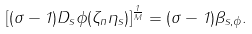<formula> <loc_0><loc_0><loc_500><loc_500>[ ( \sigma - 1 ) D _ { s } \phi ( \zeta _ { n } \eta _ { s } ) ] ^ { \frac { 1 } { M } } = ( \sigma - 1 ) \beta _ { s , \phi } .</formula> 